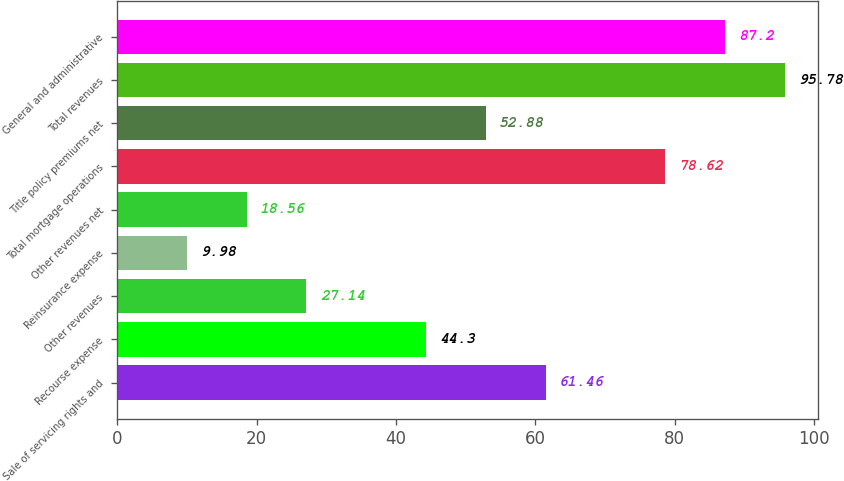Convert chart. <chart><loc_0><loc_0><loc_500><loc_500><bar_chart><fcel>Sale of servicing rights and<fcel>Recourse expense<fcel>Other revenues<fcel>Reinsurance expense<fcel>Other revenues net<fcel>Total mortgage operations<fcel>Title policy premiums net<fcel>Total revenues<fcel>General and administrative<nl><fcel>61.46<fcel>44.3<fcel>27.14<fcel>9.98<fcel>18.56<fcel>78.62<fcel>52.88<fcel>95.78<fcel>87.2<nl></chart> 